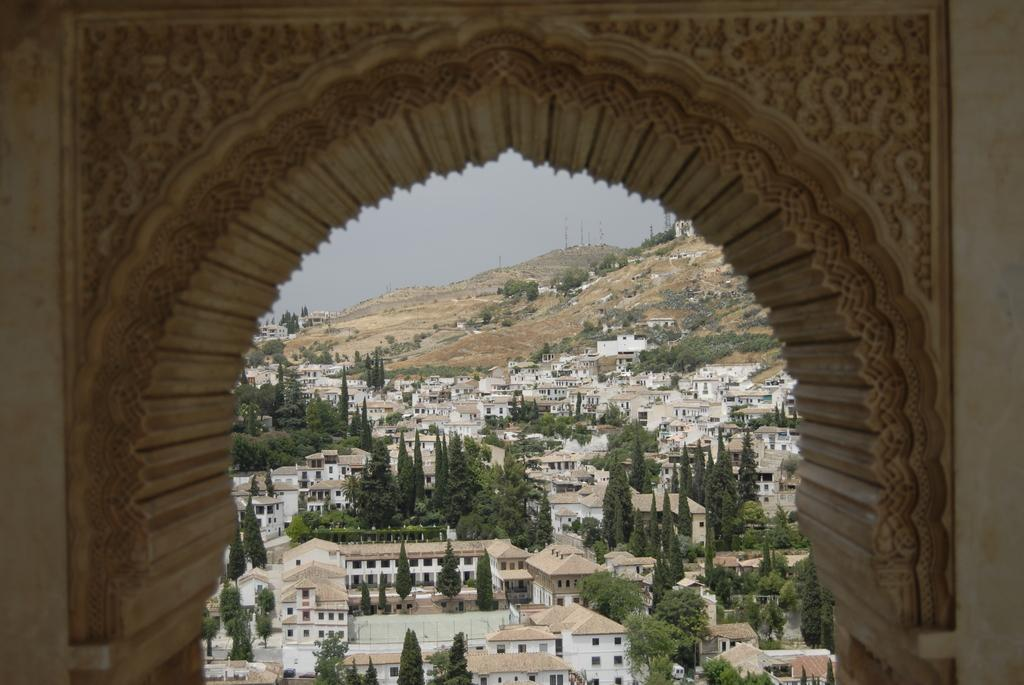What is depicted on the wall in the image? There is a wall with carvings in the image. What type of structures can be seen in the image? There are houses in the image. What other natural elements are present in the image? There are trees in the image. What can be seen in the background of the image? There is sky and a mountain visible in the background of the image. What type of crime is being committed in the image? There is no indication of any crime being committed in the image. What metal is used to create the carvings on the wall? The facts provided do not mention the material used for the carvings, so we cannot determine the type of metal used. 